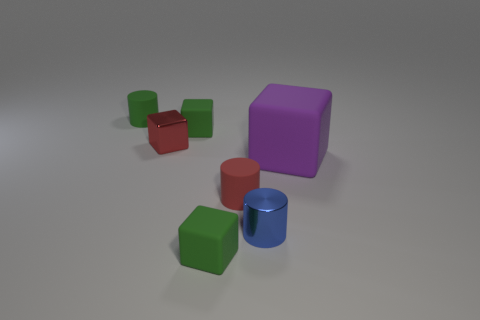Are there any other things that are the same size as the purple block?
Offer a terse response. No. What color is the small cylinder that is the same material as the red cube?
Provide a succinct answer. Blue. Is the green thing that is in front of the blue shiny cylinder made of the same material as the tiny green block behind the small shiny cylinder?
Give a very brief answer. Yes. Are there any shiny spheres of the same size as the red metallic cube?
Your answer should be compact. No. What size is the rubber cube in front of the small red matte object that is in front of the big matte cube?
Provide a succinct answer. Small. How many rubber things have the same color as the tiny metal block?
Offer a terse response. 1. There is a metallic thing that is right of the tiny block in front of the tiny red block; what is its shape?
Ensure brevity in your answer.  Cylinder. How many green things are made of the same material as the tiny red cylinder?
Offer a terse response. 3. What is the tiny green cube behind the big purple object made of?
Your answer should be compact. Rubber. What is the shape of the green rubber object that is in front of the metal object that is on the left side of the green rubber thing that is in front of the red cylinder?
Offer a terse response. Cube. 